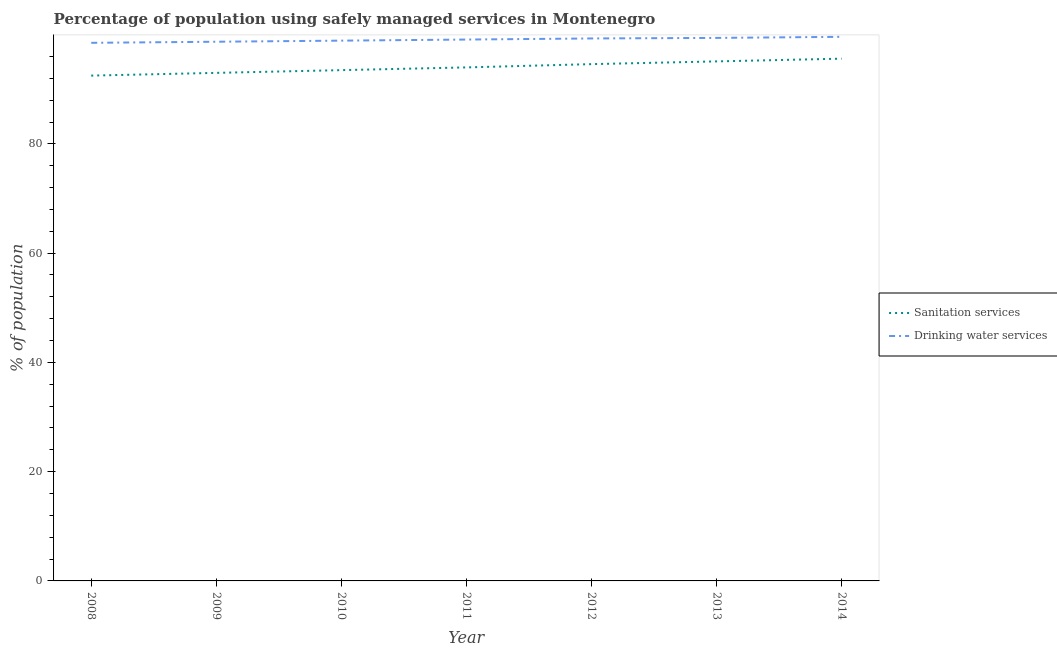How many different coloured lines are there?
Provide a short and direct response. 2. Does the line corresponding to percentage of population who used sanitation services intersect with the line corresponding to percentage of population who used drinking water services?
Provide a succinct answer. No. What is the percentage of population who used drinking water services in 2012?
Keep it short and to the point. 99.3. Across all years, what is the maximum percentage of population who used sanitation services?
Give a very brief answer. 95.6. Across all years, what is the minimum percentage of population who used drinking water services?
Your response must be concise. 98.5. In which year was the percentage of population who used drinking water services maximum?
Your response must be concise. 2014. In which year was the percentage of population who used drinking water services minimum?
Make the answer very short. 2008. What is the total percentage of population who used drinking water services in the graph?
Ensure brevity in your answer.  693.5. What is the difference between the percentage of population who used sanitation services in 2011 and that in 2013?
Provide a succinct answer. -1.1. What is the difference between the percentage of population who used drinking water services in 2012 and the percentage of population who used sanitation services in 2013?
Offer a terse response. 4.2. What is the average percentage of population who used sanitation services per year?
Make the answer very short. 94.04. In the year 2010, what is the difference between the percentage of population who used sanitation services and percentage of population who used drinking water services?
Ensure brevity in your answer.  -5.4. What is the ratio of the percentage of population who used sanitation services in 2009 to that in 2011?
Provide a short and direct response. 0.99. Is the difference between the percentage of population who used drinking water services in 2008 and 2012 greater than the difference between the percentage of population who used sanitation services in 2008 and 2012?
Keep it short and to the point. Yes. What is the difference between the highest and the second highest percentage of population who used drinking water services?
Offer a terse response. 0.2. What is the difference between the highest and the lowest percentage of population who used drinking water services?
Ensure brevity in your answer.  1.1. In how many years, is the percentage of population who used sanitation services greater than the average percentage of population who used sanitation services taken over all years?
Your answer should be compact. 3. Is the sum of the percentage of population who used sanitation services in 2009 and 2014 greater than the maximum percentage of population who used drinking water services across all years?
Your answer should be very brief. Yes. Does the percentage of population who used sanitation services monotonically increase over the years?
Make the answer very short. Yes. Is the percentage of population who used drinking water services strictly greater than the percentage of population who used sanitation services over the years?
Give a very brief answer. Yes. How many lines are there?
Offer a terse response. 2. What is the difference between two consecutive major ticks on the Y-axis?
Give a very brief answer. 20. Are the values on the major ticks of Y-axis written in scientific E-notation?
Offer a very short reply. No. Does the graph contain any zero values?
Offer a terse response. No. Does the graph contain grids?
Keep it short and to the point. No. Where does the legend appear in the graph?
Your response must be concise. Center right. How many legend labels are there?
Your answer should be compact. 2. How are the legend labels stacked?
Offer a very short reply. Vertical. What is the title of the graph?
Your answer should be very brief. Percentage of population using safely managed services in Montenegro. Does "Mineral" appear as one of the legend labels in the graph?
Keep it short and to the point. No. What is the label or title of the Y-axis?
Provide a short and direct response. % of population. What is the % of population in Sanitation services in 2008?
Offer a very short reply. 92.5. What is the % of population of Drinking water services in 2008?
Make the answer very short. 98.5. What is the % of population in Sanitation services in 2009?
Your response must be concise. 93. What is the % of population in Drinking water services in 2009?
Give a very brief answer. 98.7. What is the % of population of Sanitation services in 2010?
Provide a short and direct response. 93.5. What is the % of population of Drinking water services in 2010?
Offer a terse response. 98.9. What is the % of population of Sanitation services in 2011?
Ensure brevity in your answer.  94. What is the % of population in Drinking water services in 2011?
Make the answer very short. 99.1. What is the % of population in Sanitation services in 2012?
Give a very brief answer. 94.6. What is the % of population in Drinking water services in 2012?
Your answer should be compact. 99.3. What is the % of population in Sanitation services in 2013?
Provide a short and direct response. 95.1. What is the % of population of Drinking water services in 2013?
Make the answer very short. 99.4. What is the % of population in Sanitation services in 2014?
Provide a short and direct response. 95.6. What is the % of population of Drinking water services in 2014?
Give a very brief answer. 99.6. Across all years, what is the maximum % of population of Sanitation services?
Keep it short and to the point. 95.6. Across all years, what is the maximum % of population in Drinking water services?
Your response must be concise. 99.6. Across all years, what is the minimum % of population in Sanitation services?
Offer a very short reply. 92.5. Across all years, what is the minimum % of population in Drinking water services?
Give a very brief answer. 98.5. What is the total % of population of Sanitation services in the graph?
Your answer should be compact. 658.3. What is the total % of population in Drinking water services in the graph?
Offer a very short reply. 693.5. What is the difference between the % of population of Sanitation services in 2008 and that in 2009?
Your response must be concise. -0.5. What is the difference between the % of population in Drinking water services in 2008 and that in 2011?
Your response must be concise. -0.6. What is the difference between the % of population in Sanitation services in 2008 and that in 2012?
Provide a short and direct response. -2.1. What is the difference between the % of population in Drinking water services in 2008 and that in 2013?
Provide a short and direct response. -0.9. What is the difference between the % of population in Sanitation services in 2008 and that in 2014?
Your answer should be compact. -3.1. What is the difference between the % of population in Drinking water services in 2008 and that in 2014?
Give a very brief answer. -1.1. What is the difference between the % of population of Sanitation services in 2009 and that in 2013?
Provide a succinct answer. -2.1. What is the difference between the % of population in Drinking water services in 2009 and that in 2013?
Provide a short and direct response. -0.7. What is the difference between the % of population of Sanitation services in 2009 and that in 2014?
Provide a succinct answer. -2.6. What is the difference between the % of population of Sanitation services in 2010 and that in 2011?
Offer a terse response. -0.5. What is the difference between the % of population in Drinking water services in 2010 and that in 2011?
Provide a succinct answer. -0.2. What is the difference between the % of population in Sanitation services in 2010 and that in 2013?
Provide a succinct answer. -1.6. What is the difference between the % of population of Sanitation services in 2011 and that in 2012?
Your answer should be very brief. -0.6. What is the difference between the % of population in Sanitation services in 2011 and that in 2013?
Ensure brevity in your answer.  -1.1. What is the difference between the % of population of Drinking water services in 2011 and that in 2013?
Offer a terse response. -0.3. What is the difference between the % of population in Drinking water services in 2011 and that in 2014?
Your answer should be compact. -0.5. What is the difference between the % of population of Sanitation services in 2012 and that in 2013?
Your response must be concise. -0.5. What is the difference between the % of population in Sanitation services in 2012 and that in 2014?
Make the answer very short. -1. What is the difference between the % of population of Drinking water services in 2012 and that in 2014?
Your answer should be compact. -0.3. What is the difference between the % of population in Sanitation services in 2013 and that in 2014?
Your response must be concise. -0.5. What is the difference between the % of population in Drinking water services in 2013 and that in 2014?
Offer a terse response. -0.2. What is the difference between the % of population in Sanitation services in 2008 and the % of population in Drinking water services in 2009?
Make the answer very short. -6.2. What is the difference between the % of population in Sanitation services in 2008 and the % of population in Drinking water services in 2011?
Offer a terse response. -6.6. What is the difference between the % of population in Sanitation services in 2009 and the % of population in Drinking water services in 2010?
Keep it short and to the point. -5.9. What is the difference between the % of population of Sanitation services in 2009 and the % of population of Drinking water services in 2011?
Your answer should be very brief. -6.1. What is the difference between the % of population in Sanitation services in 2009 and the % of population in Drinking water services in 2012?
Your answer should be very brief. -6.3. What is the difference between the % of population in Sanitation services in 2009 and the % of population in Drinking water services in 2013?
Provide a succinct answer. -6.4. What is the difference between the % of population of Sanitation services in 2010 and the % of population of Drinking water services in 2014?
Ensure brevity in your answer.  -6.1. What is the difference between the % of population of Sanitation services in 2011 and the % of population of Drinking water services in 2012?
Provide a succinct answer. -5.3. What is the difference between the % of population in Sanitation services in 2011 and the % of population in Drinking water services in 2014?
Keep it short and to the point. -5.6. What is the difference between the % of population of Sanitation services in 2013 and the % of population of Drinking water services in 2014?
Your answer should be very brief. -4.5. What is the average % of population of Sanitation services per year?
Your answer should be very brief. 94.04. What is the average % of population in Drinking water services per year?
Provide a short and direct response. 99.07. In the year 2011, what is the difference between the % of population of Sanitation services and % of population of Drinking water services?
Ensure brevity in your answer.  -5.1. What is the ratio of the % of population of Sanitation services in 2008 to that in 2009?
Keep it short and to the point. 0.99. What is the ratio of the % of population of Drinking water services in 2008 to that in 2009?
Make the answer very short. 1. What is the ratio of the % of population in Sanitation services in 2008 to that in 2010?
Your answer should be very brief. 0.99. What is the ratio of the % of population in Drinking water services in 2008 to that in 2010?
Keep it short and to the point. 1. What is the ratio of the % of population of Sanitation services in 2008 to that in 2011?
Offer a terse response. 0.98. What is the ratio of the % of population of Sanitation services in 2008 to that in 2012?
Offer a terse response. 0.98. What is the ratio of the % of population in Sanitation services in 2008 to that in 2013?
Provide a short and direct response. 0.97. What is the ratio of the % of population of Drinking water services in 2008 to that in 2013?
Your answer should be compact. 0.99. What is the ratio of the % of population of Sanitation services in 2008 to that in 2014?
Keep it short and to the point. 0.97. What is the ratio of the % of population of Sanitation services in 2009 to that in 2011?
Your response must be concise. 0.99. What is the ratio of the % of population of Drinking water services in 2009 to that in 2011?
Provide a succinct answer. 1. What is the ratio of the % of population in Sanitation services in 2009 to that in 2012?
Your response must be concise. 0.98. What is the ratio of the % of population of Drinking water services in 2009 to that in 2012?
Ensure brevity in your answer.  0.99. What is the ratio of the % of population in Sanitation services in 2009 to that in 2013?
Ensure brevity in your answer.  0.98. What is the ratio of the % of population of Sanitation services in 2009 to that in 2014?
Keep it short and to the point. 0.97. What is the ratio of the % of population in Drinking water services in 2009 to that in 2014?
Your answer should be compact. 0.99. What is the ratio of the % of population in Sanitation services in 2010 to that in 2011?
Your response must be concise. 0.99. What is the ratio of the % of population in Drinking water services in 2010 to that in 2011?
Your answer should be very brief. 1. What is the ratio of the % of population of Sanitation services in 2010 to that in 2012?
Ensure brevity in your answer.  0.99. What is the ratio of the % of population in Drinking water services in 2010 to that in 2012?
Your answer should be very brief. 1. What is the ratio of the % of population in Sanitation services in 2010 to that in 2013?
Your response must be concise. 0.98. What is the ratio of the % of population of Drinking water services in 2010 to that in 2013?
Your answer should be compact. 0.99. What is the ratio of the % of population of Drinking water services in 2011 to that in 2012?
Your response must be concise. 1. What is the ratio of the % of population of Sanitation services in 2011 to that in 2013?
Give a very brief answer. 0.99. What is the ratio of the % of population in Drinking water services in 2011 to that in 2013?
Your answer should be very brief. 1. What is the ratio of the % of population of Sanitation services in 2011 to that in 2014?
Make the answer very short. 0.98. What is the ratio of the % of population of Drinking water services in 2011 to that in 2014?
Keep it short and to the point. 0.99. What is the ratio of the % of population of Sanitation services in 2012 to that in 2013?
Provide a succinct answer. 0.99. What is the ratio of the % of population of Drinking water services in 2012 to that in 2014?
Your answer should be compact. 1. What is the ratio of the % of population of Sanitation services in 2013 to that in 2014?
Ensure brevity in your answer.  0.99. What is the ratio of the % of population of Drinking water services in 2013 to that in 2014?
Offer a terse response. 1. What is the difference between the highest and the lowest % of population of Sanitation services?
Provide a succinct answer. 3.1. 